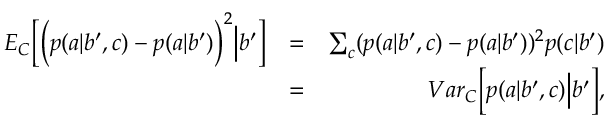<formula> <loc_0><loc_0><loc_500><loc_500>\begin{array} { r l r } { { E } _ { C } \left [ \left ( p ( a | b ^ { \prime } , c ) - p ( a | b ^ { \prime } ) \right ) ^ { 2 } \left | b ^ { \prime } \right ] } & { = } & { \sum _ { c } ( p ( a | b ^ { \prime } , c ) - p ( a | b ^ { \prime } ) ) ^ { 2 } p ( c | b ^ { \prime } ) } \\ & { = } & { { V a r } _ { C } \left [ p ( a | b ^ { \prime } , c ) \right | b ^ { \prime } \right ] , } \end{array}</formula> 